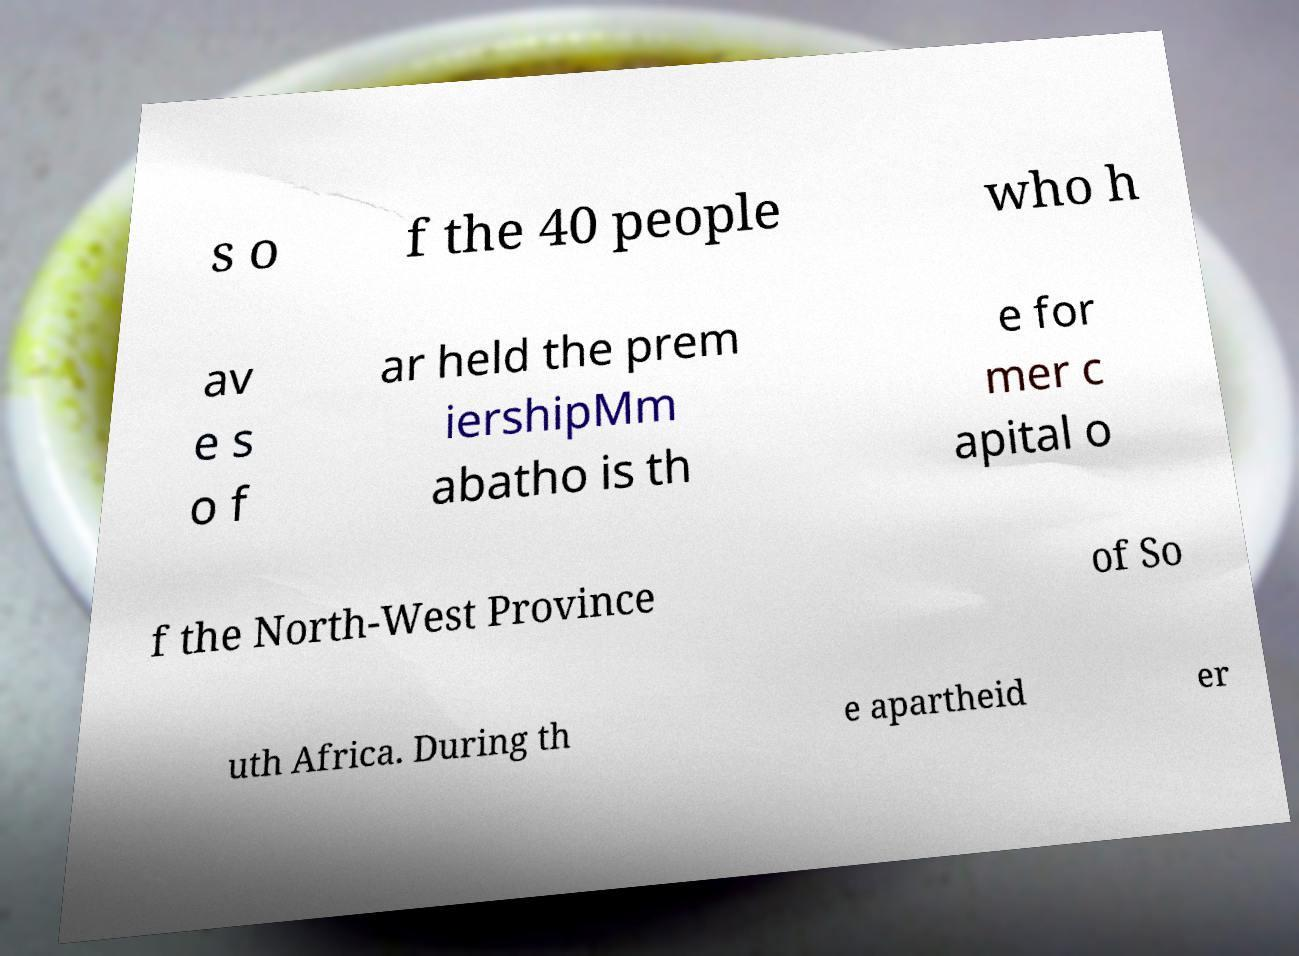Could you assist in decoding the text presented in this image and type it out clearly? s o f the 40 people who h av e s o f ar held the prem iershipMm abatho is th e for mer c apital o f the North-West Province of So uth Africa. During th e apartheid er 